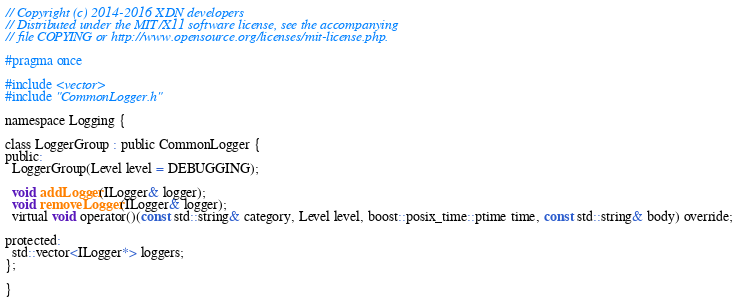<code> <loc_0><loc_0><loc_500><loc_500><_C_>
// Copyright (c) 2014-2016 XDN developers
// Distributed under the MIT/X11 software license, see the accompanying
// file COPYING or http://www.opensource.org/licenses/mit-license.php.

#pragma once

#include <vector>
#include "CommonLogger.h"

namespace Logging {

class LoggerGroup : public CommonLogger {
public:
  LoggerGroup(Level level = DEBUGGING);

  void addLogger(ILogger& logger);
  void removeLogger(ILogger& logger);
  virtual void operator()(const std::string& category, Level level, boost::posix_time::ptime time, const std::string& body) override;

protected:
  std::vector<ILogger*> loggers;
};

}
</code> 